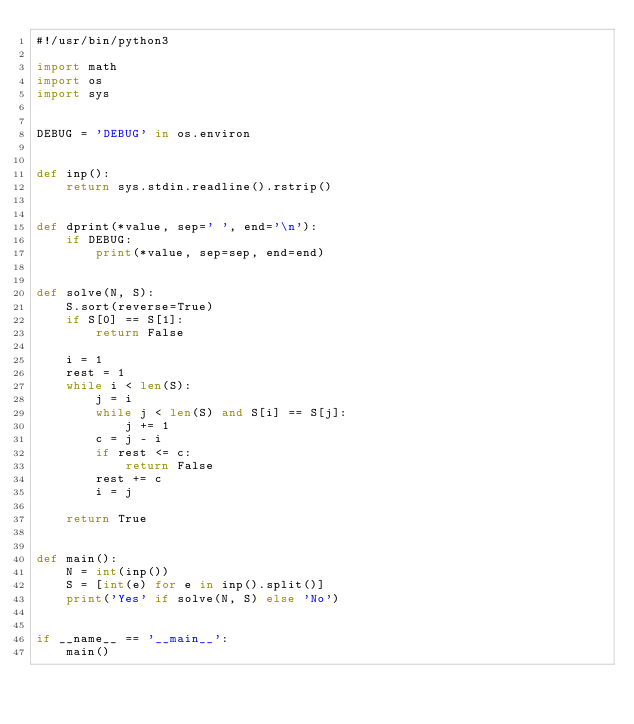Convert code to text. <code><loc_0><loc_0><loc_500><loc_500><_Python_>#!/usr/bin/python3

import math
import os
import sys


DEBUG = 'DEBUG' in os.environ


def inp():
    return sys.stdin.readline().rstrip()


def dprint(*value, sep=' ', end='\n'):
    if DEBUG:
        print(*value, sep=sep, end=end)


def solve(N, S):
    S.sort(reverse=True)
    if S[0] == S[1]:
        return False

    i = 1
    rest = 1
    while i < len(S):
        j = i
        while j < len(S) and S[i] == S[j]:
            j += 1
        c = j - i
        if rest <= c:
            return False
        rest += c
        i = j

    return True


def main():
    N = int(inp())
    S = [int(e) for e in inp().split()]
    print('Yes' if solve(N, S) else 'No')


if __name__ == '__main__':
    main()
</code> 